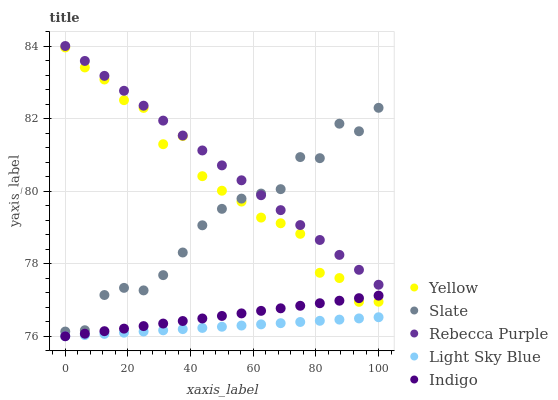Does Light Sky Blue have the minimum area under the curve?
Answer yes or no. Yes. Does Rebecca Purple have the maximum area under the curve?
Answer yes or no. Yes. Does Indigo have the minimum area under the curve?
Answer yes or no. No. Does Indigo have the maximum area under the curve?
Answer yes or no. No. Is Rebecca Purple the smoothest?
Answer yes or no. Yes. Is Yellow the roughest?
Answer yes or no. Yes. Is Light Sky Blue the smoothest?
Answer yes or no. No. Is Light Sky Blue the roughest?
Answer yes or no. No. Does Light Sky Blue have the lowest value?
Answer yes or no. Yes. Does Rebecca Purple have the lowest value?
Answer yes or no. No. Does Rebecca Purple have the highest value?
Answer yes or no. Yes. Does Indigo have the highest value?
Answer yes or no. No. Is Light Sky Blue less than Rebecca Purple?
Answer yes or no. Yes. Is Slate greater than Indigo?
Answer yes or no. Yes. Does Slate intersect Rebecca Purple?
Answer yes or no. Yes. Is Slate less than Rebecca Purple?
Answer yes or no. No. Is Slate greater than Rebecca Purple?
Answer yes or no. No. Does Light Sky Blue intersect Rebecca Purple?
Answer yes or no. No. 